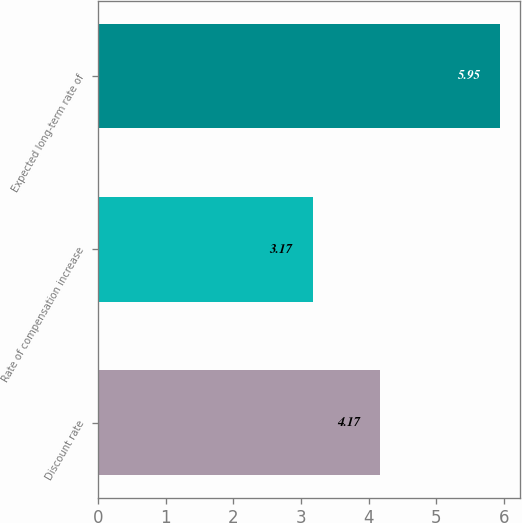<chart> <loc_0><loc_0><loc_500><loc_500><bar_chart><fcel>Discount rate<fcel>Rate of compensation increase<fcel>Expected long-term rate of<nl><fcel>4.17<fcel>3.17<fcel>5.95<nl></chart> 